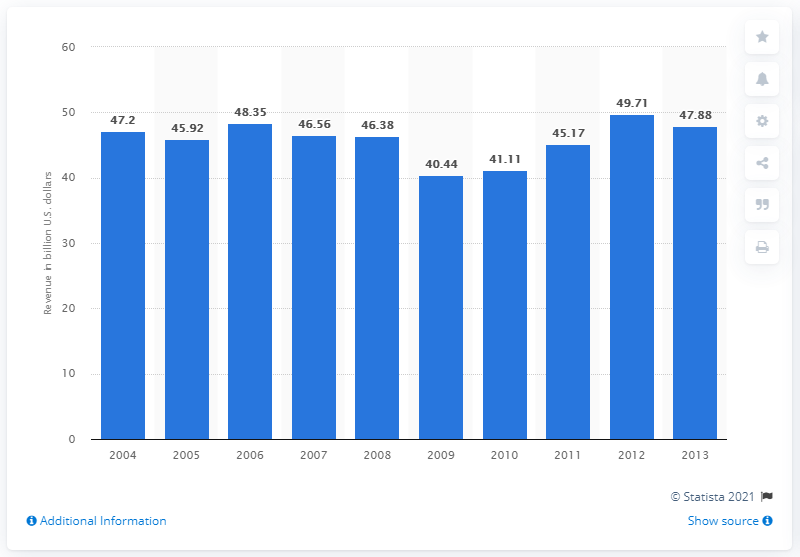Identify some key points in this picture. Advertising revenue reached its zenith in 2012. In the United States, the average amount of advertising revenues a year earlier was 49.71. In 2013, advertising generated approximately $47.88. Advertising revenue increased by 3.33% from 2008 to 2012. 